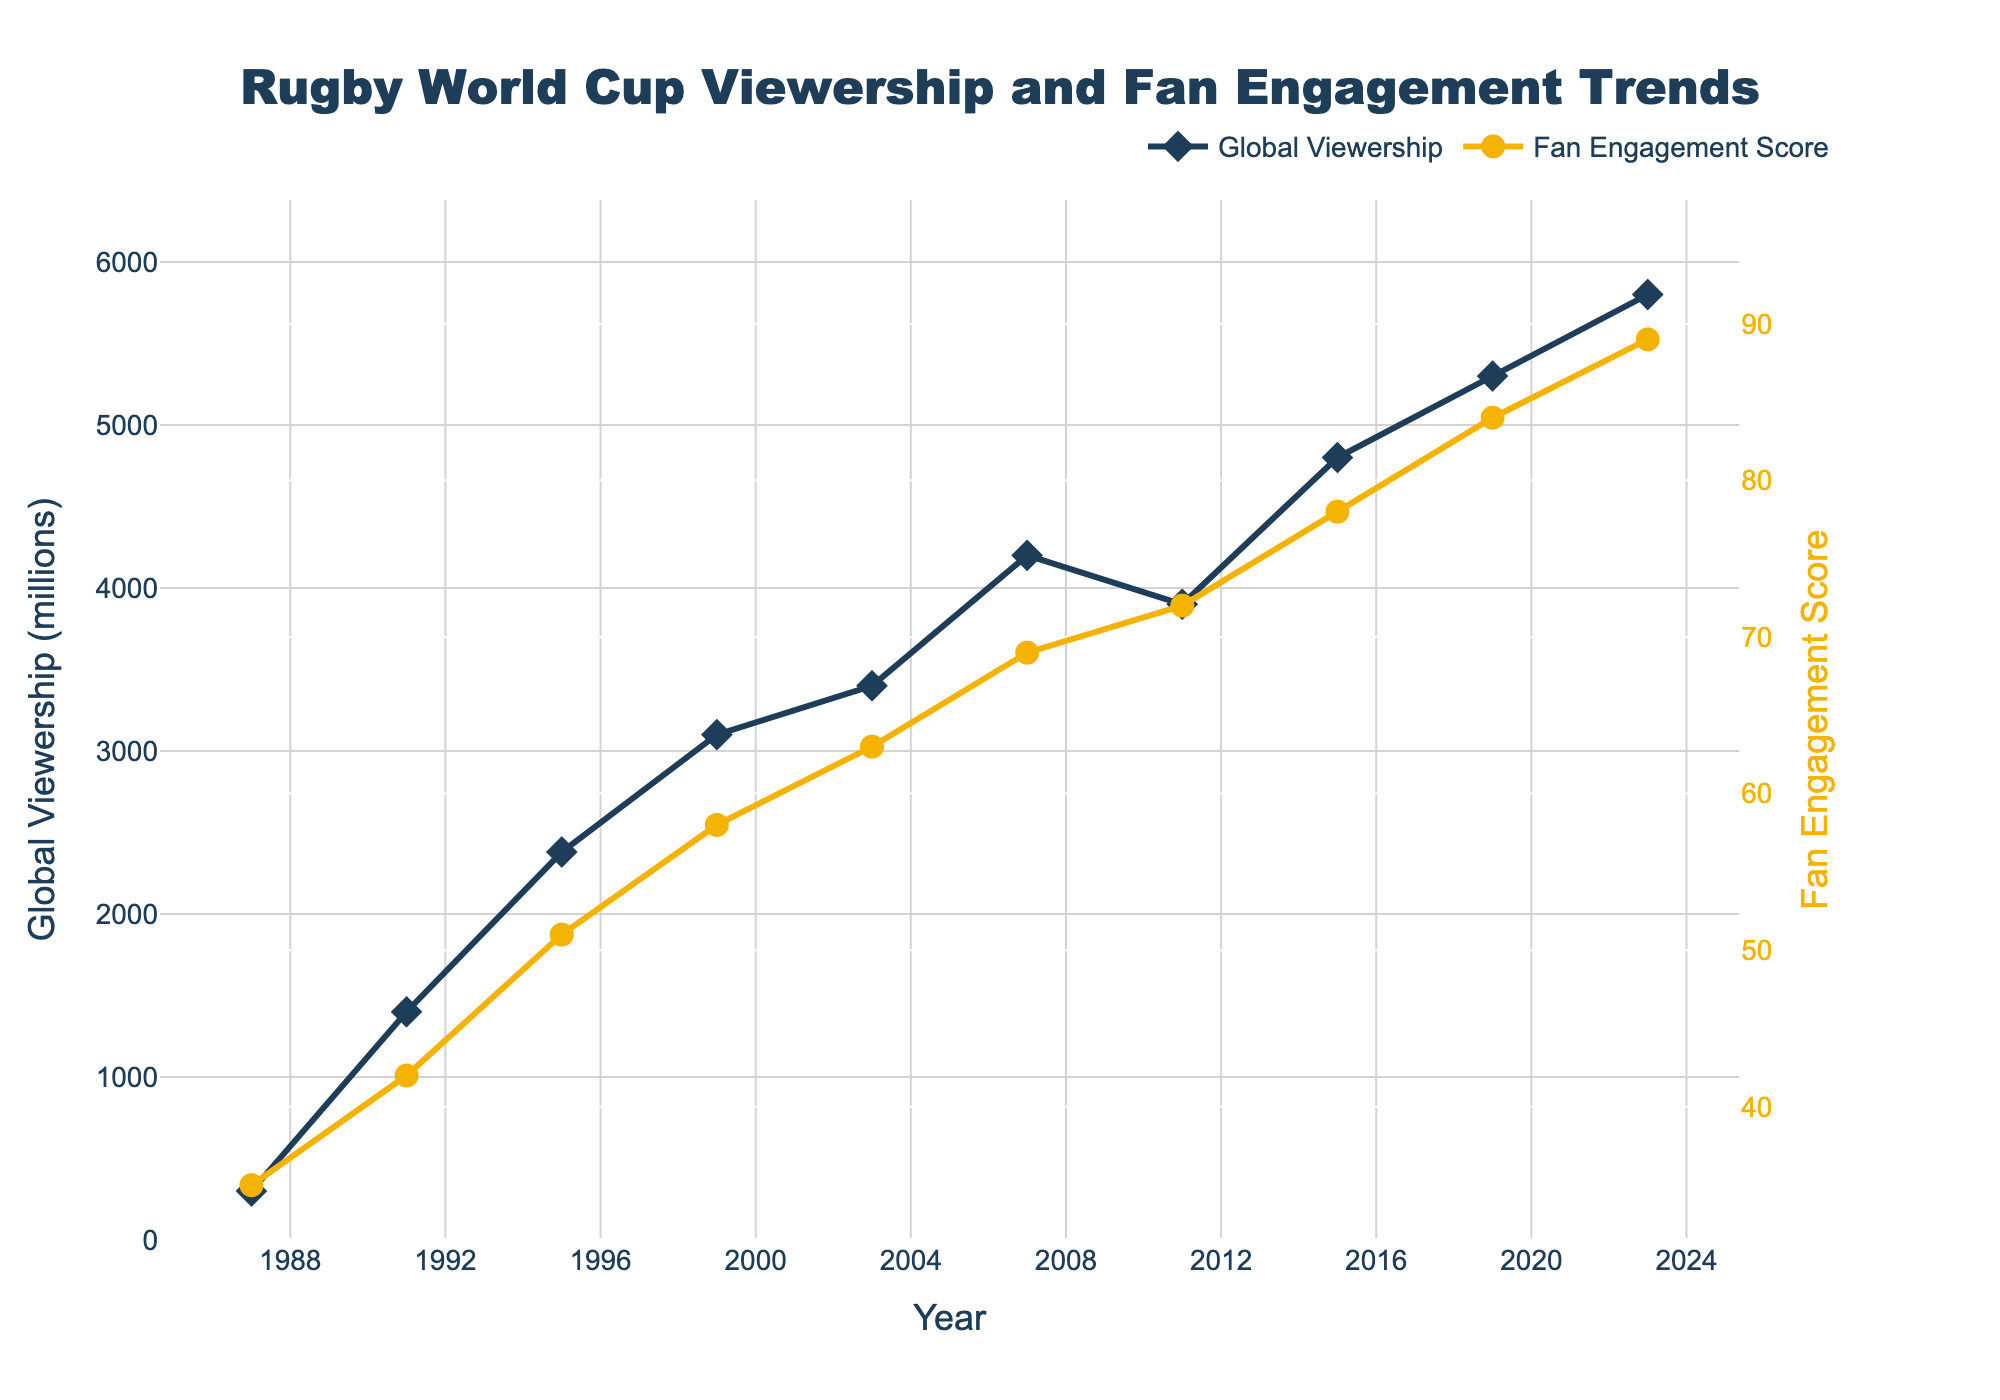How has the global viewership trend changed from 1987 to 2023? Look at the Global Viewership line (colored blue). It starts low in 1987 at 300 million, increases significantly in 1991 to 1400 million, continues an upward trend reaching 5800 million in 2023.
Answer: Increased How does the Fan Engagement Score in 2007 compare to that in 2015? Identify the Fan Engagement Score (yellow line) for the two years. In 2007 it is 69, and in 2015 it is 78.
Answer: 2015 is higher By how many millions did the global viewership increase from 2011 to 2019? Determine the viewership in 2011 (3900 million) and in 2019 (5300 million). Compute the difference: 5300 - 3900 = 1400 million.
Answer: 1400 million Which year had the highest Fan Engagement Score, and what was the score? Find the peak of the Fan Engagement line (yellow) which occurs in 2023. The score is 89.
Answer: 2023, 89 What is the difference between the global viewership in 1995 and 1991? Viewership in 1995 is 2380 million and in 1991 is 1400 million. Calculate the difference: 2380 - 1400 = 980 million.
Answer: 980 million What was the global viewership in 1999, and how does it compare with that in 2007? Viewership in 1999 is 3100 million, and in 2007 it’s 4200 million. 2007 viewership is higher by 4200 - 3100 = 1100 million.
Answer: 1999: 3100 million, 2007 is 1100 million higher In which time period did the Fan Engagement Score see the largest increase? Examine the slope of the Fan Engagement (yellow) line. The steepest slope appears between 2011 (72) and 2015 (78), an increase of 6.
Answer: 2011-2015 Is there a correlation between Global Viewership and Fan Engagement Score across the years? Observe both lines' upward trends. Both Global Viewership and Fan Engagement Score generally increase over time, suggesting a positive correlation.
Answer: Yes, positive Which year saw the smallest increase in global viewership compared to the previous year, and what was the value? Check the differences year-to-year in the blue line. From 2003 (3400) to 2007 (4200), the increase of 800 is the smallest.
Answer: 2007, 800 million From 1987 to 2023, how many years experienced a decline in global viewership? Locate years where the Global Viewership line descends. 2011 (3900) is lower than 2007 (4200).
Answer: 1 year 